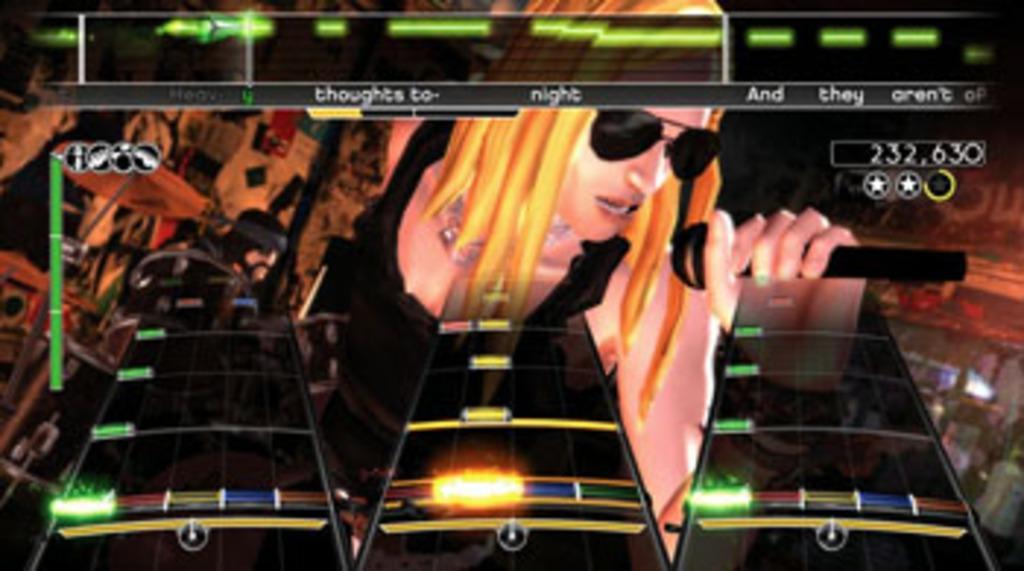Describe this image in one or two sentences. In this picture we can observe a video game screen. There is a woman, holding a mic and wearing spectacles. There are three platforms in this picture which were in black color. 